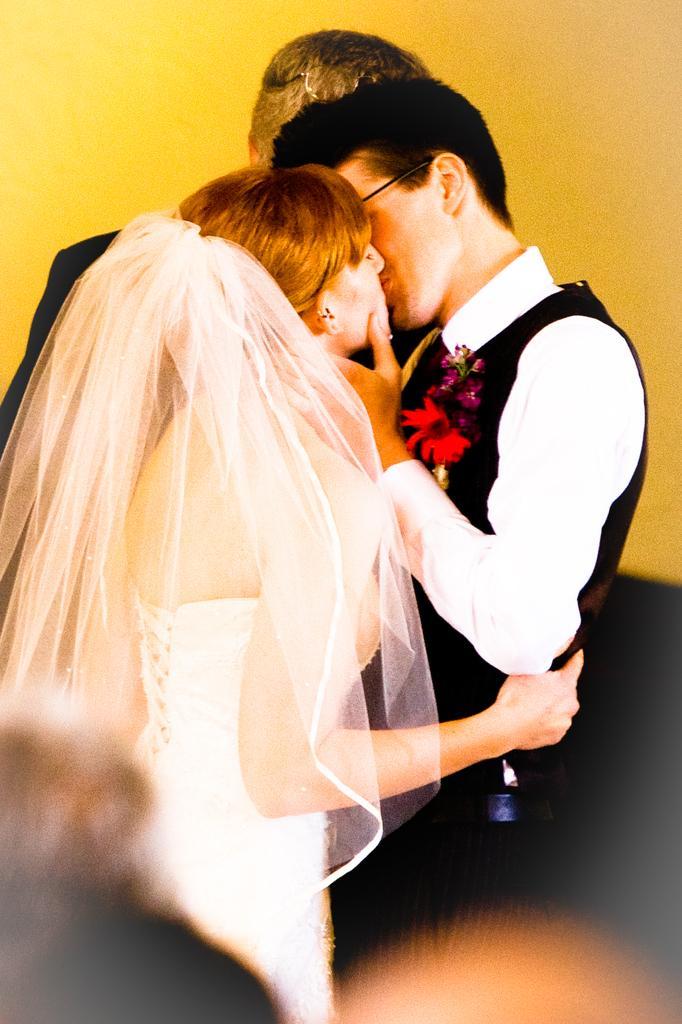In one or two sentences, can you explain what this image depicts? In this picture we can see a groom wearing black color suit and beside there is a bride wearing white color gown kissing each other. Behind there is a yellow background. 